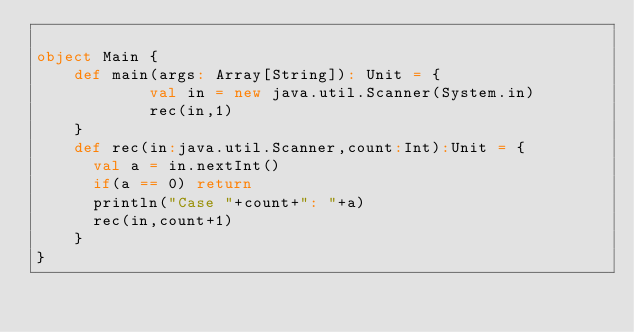<code> <loc_0><loc_0><loc_500><loc_500><_Scala_>
object Main {
	def main(args: Array[String]): Unit = {
			val in = new java.util.Scanner(System.in)
			rec(in,1)
	}
	def rec(in:java.util.Scanner,count:Int):Unit = {
	  val a = in.nextInt()
	  if(a == 0) return
	  println("Case "+count+": "+a)
	  rec(in,count+1)
	}
}</code> 